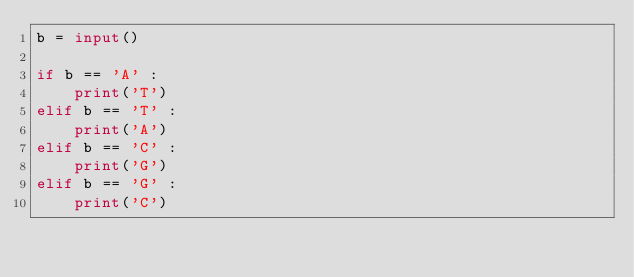Convert code to text. <code><loc_0><loc_0><loc_500><loc_500><_Python_>b = input()

if b == 'A' :
    print('T')
elif b == 'T' :
    print('A')
elif b == 'C' :
    print('G')
elif b == 'G' :
    print('C')
</code> 